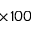<formula> <loc_0><loc_0><loc_500><loc_500>\times 1 0 0</formula> 